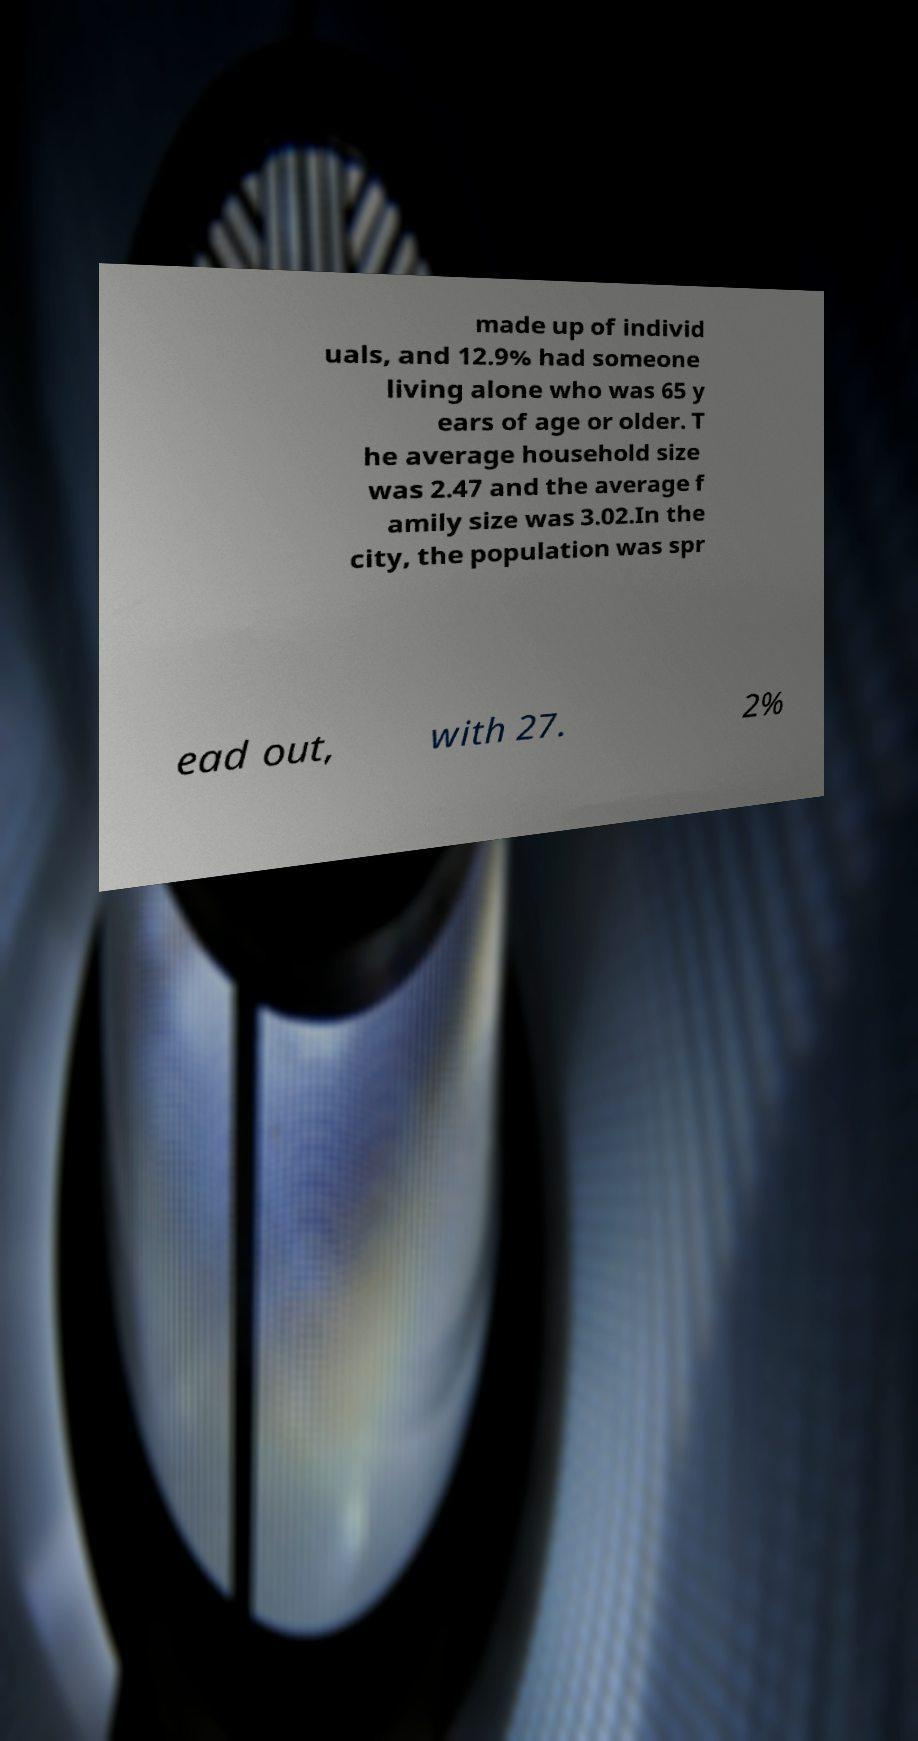Please read and relay the text visible in this image. What does it say? made up of individ uals, and 12.9% had someone living alone who was 65 y ears of age or older. T he average household size was 2.47 and the average f amily size was 3.02.In the city, the population was spr ead out, with 27. 2% 